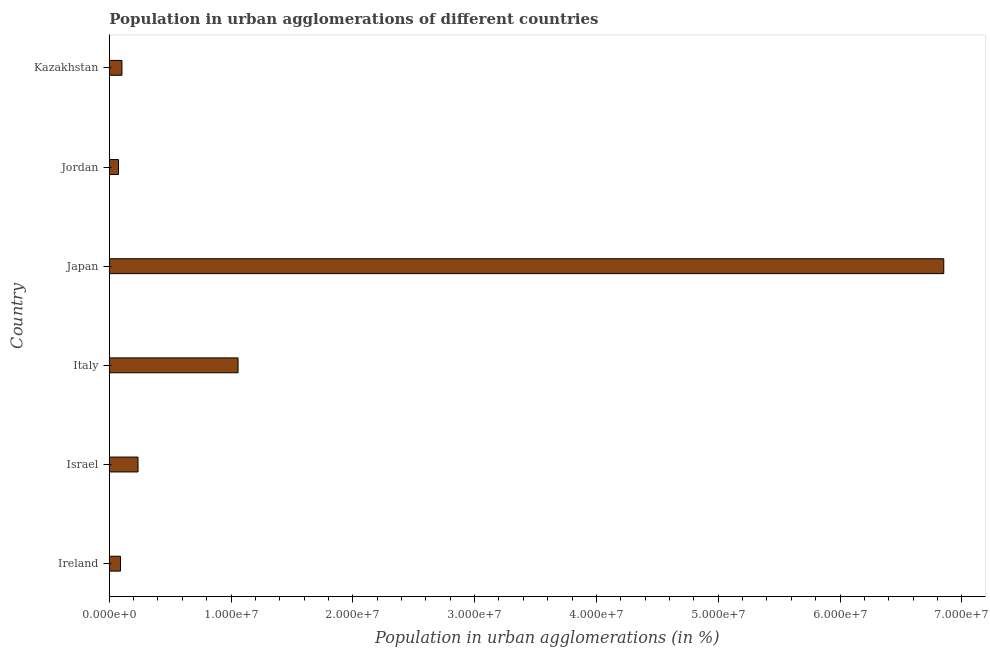Does the graph contain any zero values?
Your response must be concise. No. What is the title of the graph?
Your response must be concise. Population in urban agglomerations of different countries. What is the label or title of the X-axis?
Give a very brief answer. Population in urban agglomerations (in %). What is the population in urban agglomerations in Japan?
Keep it short and to the point. 6.85e+07. Across all countries, what is the maximum population in urban agglomerations?
Keep it short and to the point. 6.85e+07. Across all countries, what is the minimum population in urban agglomerations?
Provide a succinct answer. 7.58e+05. In which country was the population in urban agglomerations minimum?
Ensure brevity in your answer.  Jordan. What is the sum of the population in urban agglomerations?
Provide a short and direct response. 8.42e+07. What is the difference between the population in urban agglomerations in Ireland and Italy?
Your response must be concise. -9.65e+06. What is the average population in urban agglomerations per country?
Your answer should be very brief. 1.40e+07. What is the median population in urban agglomerations?
Ensure brevity in your answer.  1.70e+06. In how many countries, is the population in urban agglomerations greater than 20000000 %?
Offer a terse response. 1. What is the ratio of the population in urban agglomerations in Israel to that in Italy?
Keep it short and to the point. 0.22. What is the difference between the highest and the second highest population in urban agglomerations?
Offer a terse response. 5.79e+07. Is the sum of the population in urban agglomerations in Japan and Jordan greater than the maximum population in urban agglomerations across all countries?
Offer a very short reply. Yes. What is the difference between the highest and the lowest population in urban agglomerations?
Offer a very short reply. 6.78e+07. In how many countries, is the population in urban agglomerations greater than the average population in urban agglomerations taken over all countries?
Keep it short and to the point. 1. How many countries are there in the graph?
Offer a very short reply. 6. What is the Population in urban agglomerations (in %) in Ireland?
Ensure brevity in your answer.  9.21e+05. What is the Population in urban agglomerations (in %) in Israel?
Your answer should be compact. 2.36e+06. What is the Population in urban agglomerations (in %) of Italy?
Your answer should be compact. 1.06e+07. What is the Population in urban agglomerations (in %) of Japan?
Offer a very short reply. 6.85e+07. What is the Population in urban agglomerations (in %) in Jordan?
Your answer should be very brief. 7.58e+05. What is the Population in urban agglomerations (in %) of Kazakhstan?
Provide a short and direct response. 1.04e+06. What is the difference between the Population in urban agglomerations (in %) in Ireland and Israel?
Keep it short and to the point. -1.44e+06. What is the difference between the Population in urban agglomerations (in %) in Ireland and Italy?
Make the answer very short. -9.65e+06. What is the difference between the Population in urban agglomerations (in %) in Ireland and Japan?
Give a very brief answer. -6.76e+07. What is the difference between the Population in urban agglomerations (in %) in Ireland and Jordan?
Your response must be concise. 1.63e+05. What is the difference between the Population in urban agglomerations (in %) in Ireland and Kazakhstan?
Your answer should be compact. -1.21e+05. What is the difference between the Population in urban agglomerations (in %) in Israel and Italy?
Make the answer very short. -8.21e+06. What is the difference between the Population in urban agglomerations (in %) in Israel and Japan?
Your answer should be compact. -6.62e+07. What is the difference between the Population in urban agglomerations (in %) in Israel and Jordan?
Keep it short and to the point. 1.60e+06. What is the difference between the Population in urban agglomerations (in %) in Israel and Kazakhstan?
Offer a terse response. 1.32e+06. What is the difference between the Population in urban agglomerations (in %) in Italy and Japan?
Provide a succinct answer. -5.79e+07. What is the difference between the Population in urban agglomerations (in %) in Italy and Jordan?
Make the answer very short. 9.82e+06. What is the difference between the Population in urban agglomerations (in %) in Italy and Kazakhstan?
Provide a short and direct response. 9.53e+06. What is the difference between the Population in urban agglomerations (in %) in Japan and Jordan?
Make the answer very short. 6.78e+07. What is the difference between the Population in urban agglomerations (in %) in Japan and Kazakhstan?
Offer a very short reply. 6.75e+07. What is the difference between the Population in urban agglomerations (in %) in Jordan and Kazakhstan?
Your answer should be compact. -2.84e+05. What is the ratio of the Population in urban agglomerations (in %) in Ireland to that in Israel?
Your answer should be very brief. 0.39. What is the ratio of the Population in urban agglomerations (in %) in Ireland to that in Italy?
Your response must be concise. 0.09. What is the ratio of the Population in urban agglomerations (in %) in Ireland to that in Japan?
Offer a very short reply. 0.01. What is the ratio of the Population in urban agglomerations (in %) in Ireland to that in Jordan?
Your response must be concise. 1.22. What is the ratio of the Population in urban agglomerations (in %) in Ireland to that in Kazakhstan?
Your answer should be very brief. 0.88. What is the ratio of the Population in urban agglomerations (in %) in Israel to that in Italy?
Your answer should be very brief. 0.22. What is the ratio of the Population in urban agglomerations (in %) in Israel to that in Japan?
Ensure brevity in your answer.  0.03. What is the ratio of the Population in urban agglomerations (in %) in Israel to that in Jordan?
Provide a short and direct response. 3.12. What is the ratio of the Population in urban agglomerations (in %) in Israel to that in Kazakhstan?
Your response must be concise. 2.27. What is the ratio of the Population in urban agglomerations (in %) in Italy to that in Japan?
Give a very brief answer. 0.15. What is the ratio of the Population in urban agglomerations (in %) in Italy to that in Jordan?
Provide a succinct answer. 13.96. What is the ratio of the Population in urban agglomerations (in %) in Italy to that in Kazakhstan?
Offer a very short reply. 10.15. What is the ratio of the Population in urban agglomerations (in %) in Japan to that in Jordan?
Give a very brief answer. 90.45. What is the ratio of the Population in urban agglomerations (in %) in Japan to that in Kazakhstan?
Keep it short and to the point. 65.79. What is the ratio of the Population in urban agglomerations (in %) in Jordan to that in Kazakhstan?
Provide a short and direct response. 0.73. 